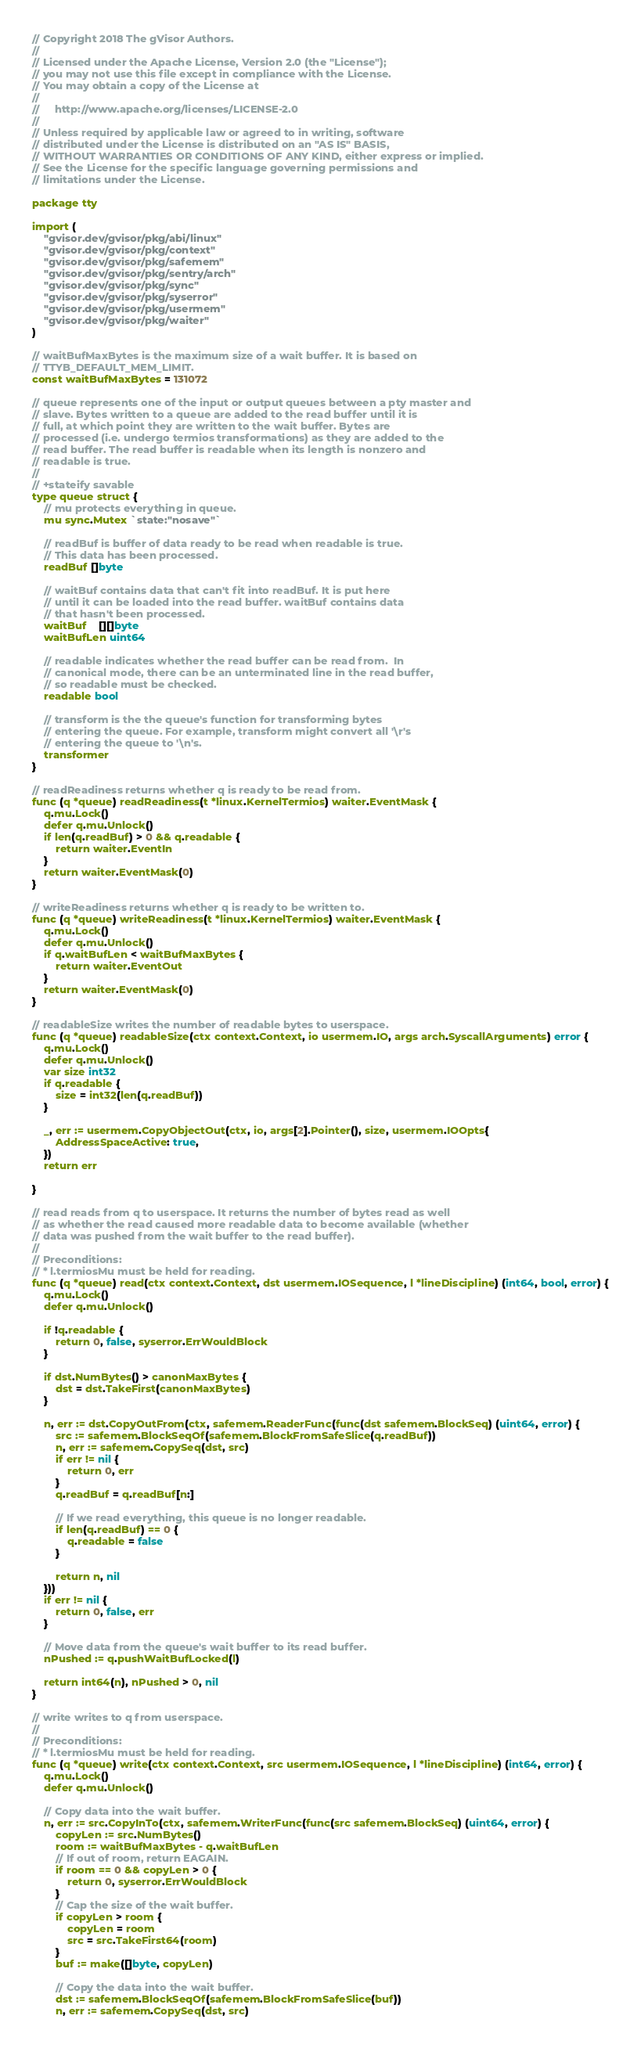<code> <loc_0><loc_0><loc_500><loc_500><_Go_>// Copyright 2018 The gVisor Authors.
//
// Licensed under the Apache License, Version 2.0 (the "License");
// you may not use this file except in compliance with the License.
// You may obtain a copy of the License at
//
//     http://www.apache.org/licenses/LICENSE-2.0
//
// Unless required by applicable law or agreed to in writing, software
// distributed under the License is distributed on an "AS IS" BASIS,
// WITHOUT WARRANTIES OR CONDITIONS OF ANY KIND, either express or implied.
// See the License for the specific language governing permissions and
// limitations under the License.

package tty

import (
	"gvisor.dev/gvisor/pkg/abi/linux"
	"gvisor.dev/gvisor/pkg/context"
	"gvisor.dev/gvisor/pkg/safemem"
	"gvisor.dev/gvisor/pkg/sentry/arch"
	"gvisor.dev/gvisor/pkg/sync"
	"gvisor.dev/gvisor/pkg/syserror"
	"gvisor.dev/gvisor/pkg/usermem"
	"gvisor.dev/gvisor/pkg/waiter"
)

// waitBufMaxBytes is the maximum size of a wait buffer. It is based on
// TTYB_DEFAULT_MEM_LIMIT.
const waitBufMaxBytes = 131072

// queue represents one of the input or output queues between a pty master and
// slave. Bytes written to a queue are added to the read buffer until it is
// full, at which point they are written to the wait buffer. Bytes are
// processed (i.e. undergo termios transformations) as they are added to the
// read buffer. The read buffer is readable when its length is nonzero and
// readable is true.
//
// +stateify savable
type queue struct {
	// mu protects everything in queue.
	mu sync.Mutex `state:"nosave"`

	// readBuf is buffer of data ready to be read when readable is true.
	// This data has been processed.
	readBuf []byte

	// waitBuf contains data that can't fit into readBuf. It is put here
	// until it can be loaded into the read buffer. waitBuf contains data
	// that hasn't been processed.
	waitBuf    [][]byte
	waitBufLen uint64

	// readable indicates whether the read buffer can be read from.  In
	// canonical mode, there can be an unterminated line in the read buffer,
	// so readable must be checked.
	readable bool

	// transform is the the queue's function for transforming bytes
	// entering the queue. For example, transform might convert all '\r's
	// entering the queue to '\n's.
	transformer
}

// readReadiness returns whether q is ready to be read from.
func (q *queue) readReadiness(t *linux.KernelTermios) waiter.EventMask {
	q.mu.Lock()
	defer q.mu.Unlock()
	if len(q.readBuf) > 0 && q.readable {
		return waiter.EventIn
	}
	return waiter.EventMask(0)
}

// writeReadiness returns whether q is ready to be written to.
func (q *queue) writeReadiness(t *linux.KernelTermios) waiter.EventMask {
	q.mu.Lock()
	defer q.mu.Unlock()
	if q.waitBufLen < waitBufMaxBytes {
		return waiter.EventOut
	}
	return waiter.EventMask(0)
}

// readableSize writes the number of readable bytes to userspace.
func (q *queue) readableSize(ctx context.Context, io usermem.IO, args arch.SyscallArguments) error {
	q.mu.Lock()
	defer q.mu.Unlock()
	var size int32
	if q.readable {
		size = int32(len(q.readBuf))
	}

	_, err := usermem.CopyObjectOut(ctx, io, args[2].Pointer(), size, usermem.IOOpts{
		AddressSpaceActive: true,
	})
	return err

}

// read reads from q to userspace. It returns the number of bytes read as well
// as whether the read caused more readable data to become available (whether
// data was pushed from the wait buffer to the read buffer).
//
// Preconditions:
// * l.termiosMu must be held for reading.
func (q *queue) read(ctx context.Context, dst usermem.IOSequence, l *lineDiscipline) (int64, bool, error) {
	q.mu.Lock()
	defer q.mu.Unlock()

	if !q.readable {
		return 0, false, syserror.ErrWouldBlock
	}

	if dst.NumBytes() > canonMaxBytes {
		dst = dst.TakeFirst(canonMaxBytes)
	}

	n, err := dst.CopyOutFrom(ctx, safemem.ReaderFunc(func(dst safemem.BlockSeq) (uint64, error) {
		src := safemem.BlockSeqOf(safemem.BlockFromSafeSlice(q.readBuf))
		n, err := safemem.CopySeq(dst, src)
		if err != nil {
			return 0, err
		}
		q.readBuf = q.readBuf[n:]

		// If we read everything, this queue is no longer readable.
		if len(q.readBuf) == 0 {
			q.readable = false
		}

		return n, nil
	}))
	if err != nil {
		return 0, false, err
	}

	// Move data from the queue's wait buffer to its read buffer.
	nPushed := q.pushWaitBufLocked(l)

	return int64(n), nPushed > 0, nil
}

// write writes to q from userspace.
//
// Preconditions:
// * l.termiosMu must be held for reading.
func (q *queue) write(ctx context.Context, src usermem.IOSequence, l *lineDiscipline) (int64, error) {
	q.mu.Lock()
	defer q.mu.Unlock()

	// Copy data into the wait buffer.
	n, err := src.CopyInTo(ctx, safemem.WriterFunc(func(src safemem.BlockSeq) (uint64, error) {
		copyLen := src.NumBytes()
		room := waitBufMaxBytes - q.waitBufLen
		// If out of room, return EAGAIN.
		if room == 0 && copyLen > 0 {
			return 0, syserror.ErrWouldBlock
		}
		// Cap the size of the wait buffer.
		if copyLen > room {
			copyLen = room
			src = src.TakeFirst64(room)
		}
		buf := make([]byte, copyLen)

		// Copy the data into the wait buffer.
		dst := safemem.BlockSeqOf(safemem.BlockFromSafeSlice(buf))
		n, err := safemem.CopySeq(dst, src)</code> 